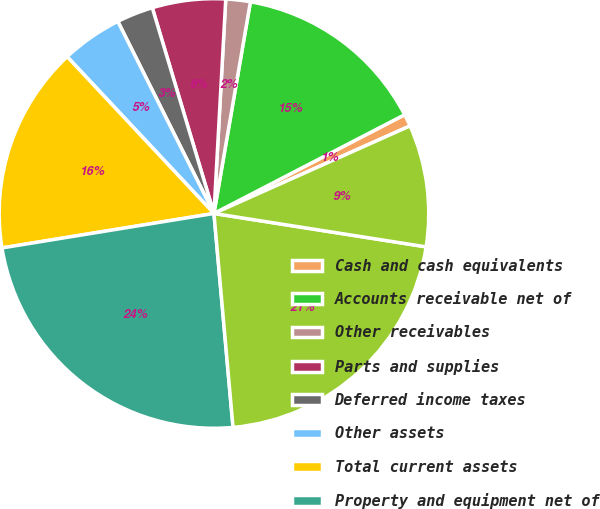<chart> <loc_0><loc_0><loc_500><loc_500><pie_chart><fcel>Cash and cash equivalents<fcel>Accounts receivable net of<fcel>Other receivables<fcel>Parts and supplies<fcel>Deferred income taxes<fcel>Other assets<fcel>Total current assets<fcel>Property and equipment net of<fcel>Goodwill<fcel>Other intangible assets net<nl><fcel>0.92%<fcel>14.68%<fcel>1.84%<fcel>5.51%<fcel>2.75%<fcel>4.59%<fcel>15.59%<fcel>23.85%<fcel>21.1%<fcel>9.17%<nl></chart> 